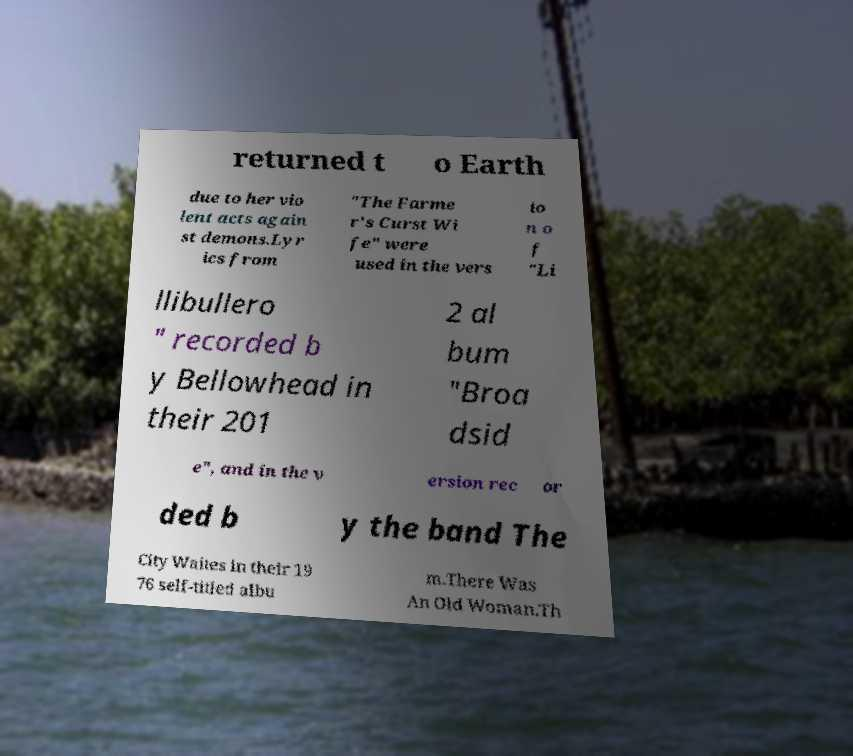Please read and relay the text visible in this image. What does it say? returned t o Earth due to her vio lent acts again st demons.Lyr ics from "The Farme r's Curst Wi fe" were used in the vers io n o f "Li llibullero " recorded b y Bellowhead in their 201 2 al bum "Broa dsid e", and in the v ersion rec or ded b y the band The City Waites in their 19 76 self-titled albu m.There Was An Old Woman.Th 